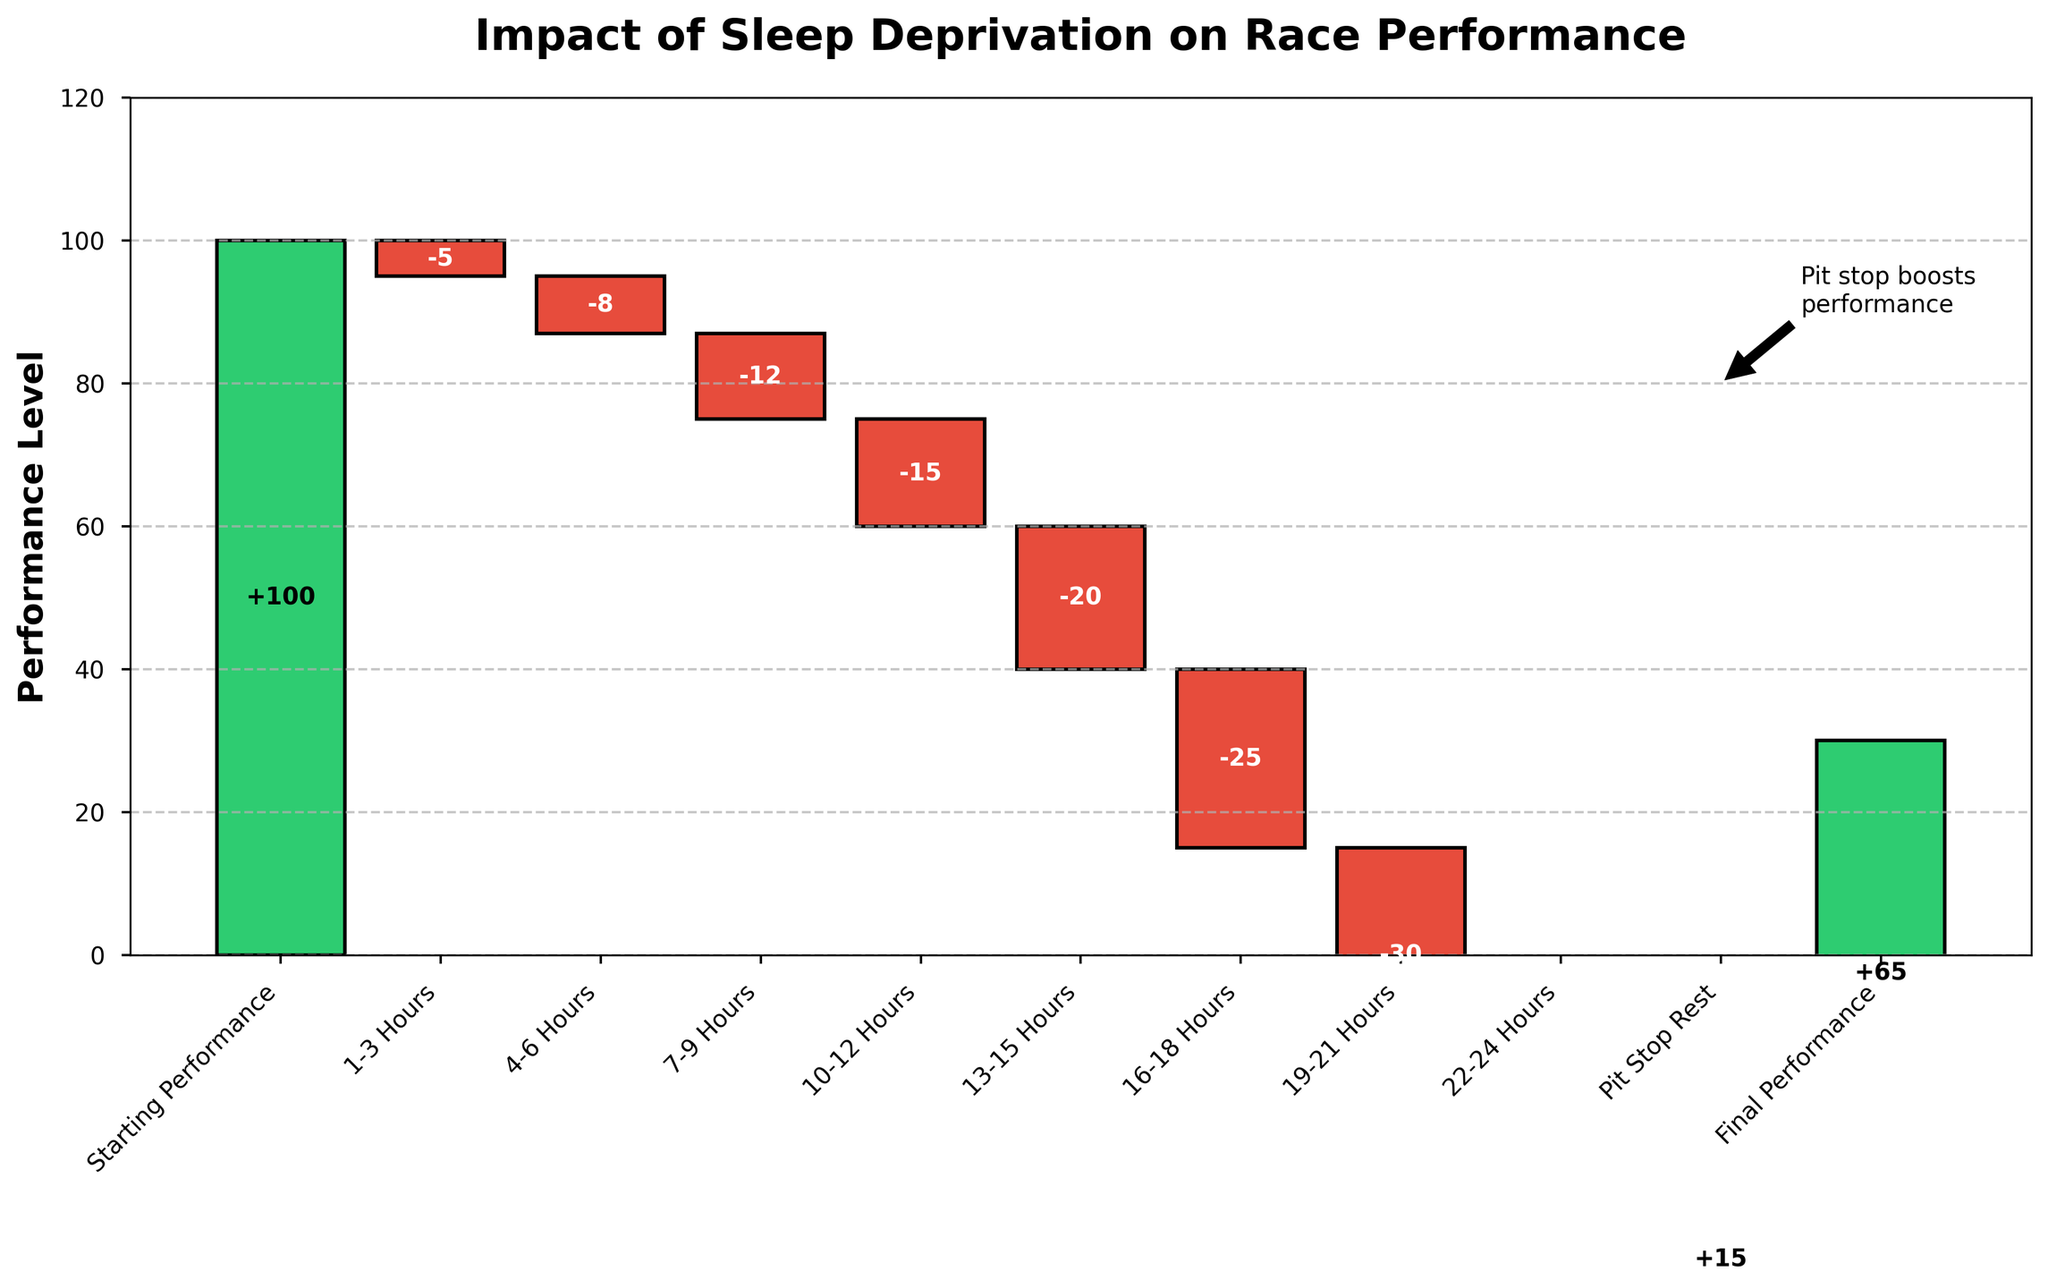What's the title of the figure? The title is usually displayed at the top of the chart. By looking at the top, you can see the text indicating the title.
Answer: Impact of Sleep Deprivation on Race Performance What's the initial performance value? The initial performance value is represented by the first bar in the waterfall chart. By reading the value displayed or the initial position at the y-axis, you can determine it.
Answer: 100 How does performance change between 7-9 hours and 10-12 hours of the race? To find the change, observe the values for the 7-9 hours (-12) and 10-12 hours (-15). Calculate the difference: -15 - (-12) = -3.
Answer: -3 What is the overall change in performance from starting to final? The overall change can be determined by subtracting the final performance value (65) from the starting performance value (100): 65 - 100.
Answer: -35 When does the largest single drop in performance occur? To identify the largest drop, compare the decreases for the different intervals. The interval with the most negative value will represent the largest drop, which is from 22-24 hours (-35).
Answer: 22-24 Hours How does performance change after the pit stop rest? Look at the value displayed for the pit stop rest (+15). This represents the increase in performance immediately after the pit stop.
Answer: +15 What is the cumulative performance loss by the time 19-21 hours are completed? To find this, sum up the negative impacts up to 19-21 hours: -5 + (-8) + (-12) + (-15) + (-20) + (-25) + (-30) = -115. Then add this to the starting performance: 100 - 115.
Answer: -115 Compare the impact on performance between the intervals of 1-3 hours and 4-6 hours. The impact on performance in the 1-3 hours is -5, and in the interval of 4-6 hours is -8. Compare these two values to see which one has a greater negative impact.
Answer: 4-6 Hours Which interval has the smallest negative impact on performance? By reviewing the values for each interval, the smallest negative impact is the least negative number, which is found in the 1-3 hours interval.
Answer: 1-3 Hours What's the difference in performance from 13-15 hours and 16-18 hours? Assess the performance values for the intervals 13-15 hours (-20) and 16-18 hours (-25). The difference can be found by subtracting: -25 - (-20) = -5.
Answer: -5 